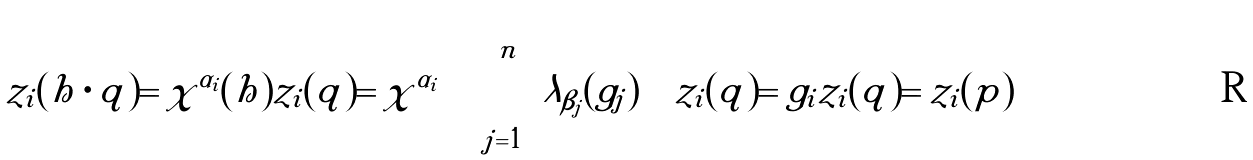<formula> <loc_0><loc_0><loc_500><loc_500>z _ { i } ( h \cdot q ) = \chi ^ { \alpha _ { i } } ( h ) z _ { i } ( q ) = \chi ^ { \alpha _ { i } } \left ( \prod _ { j = 1 } ^ { n } \lambda _ { \beta _ { j } } ( g _ { j } ) \right ) z _ { i } ( q ) = g _ { i } z _ { i } ( q ) = z _ { i } ( p )</formula> 